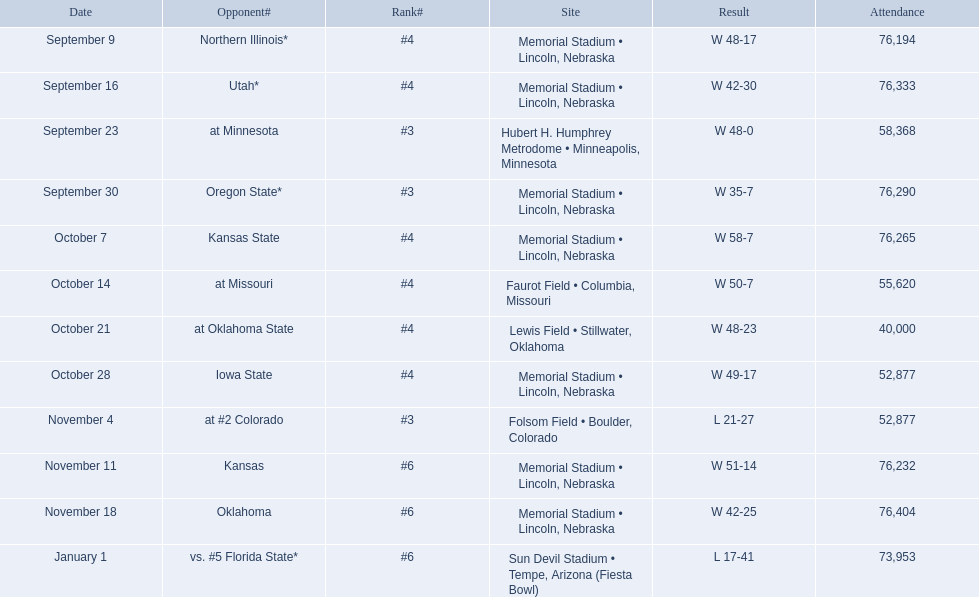When did the game between nebraska and oregon state take place? September 30. What was the number of attendees at the september 30 match? 76,290. 